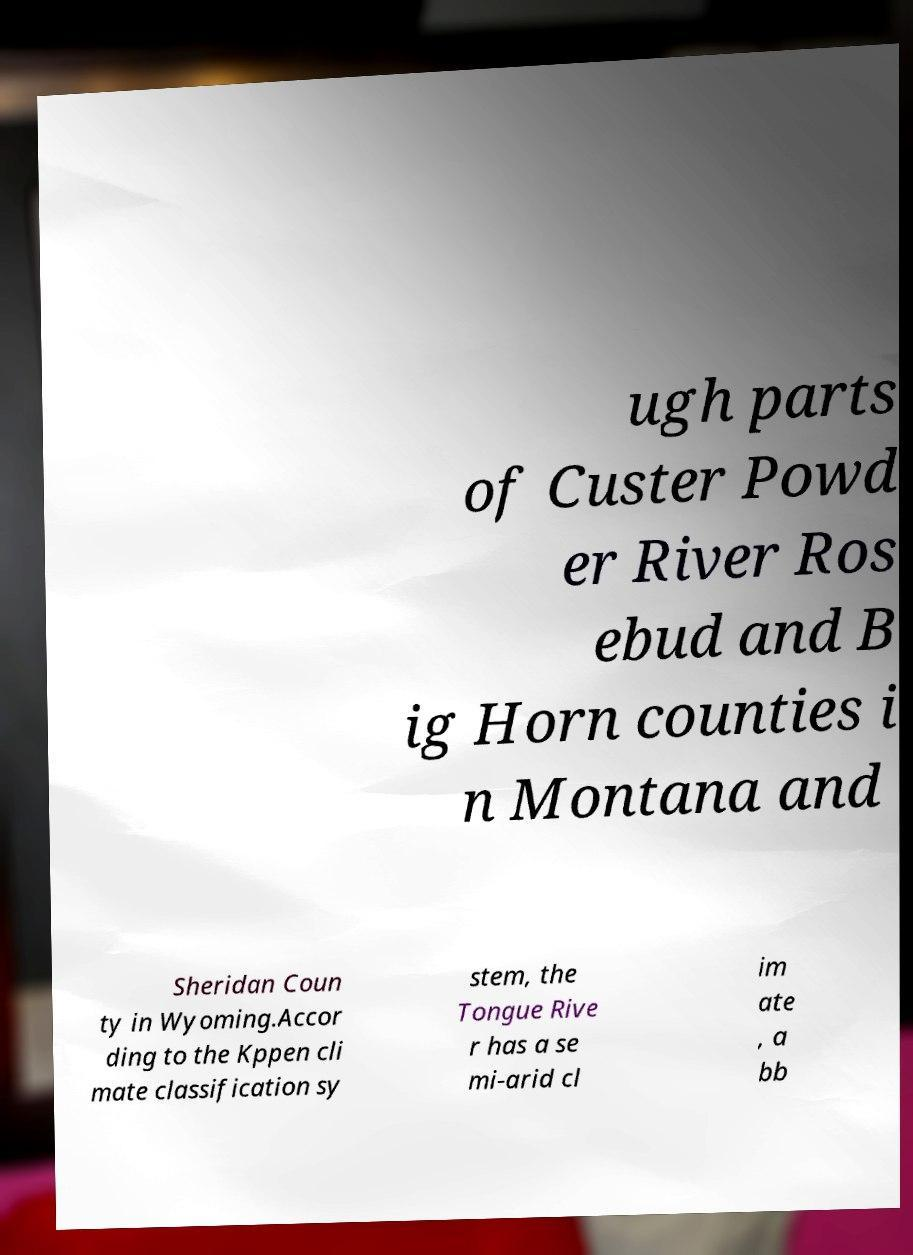I need the written content from this picture converted into text. Can you do that? ugh parts of Custer Powd er River Ros ebud and B ig Horn counties i n Montana and Sheridan Coun ty in Wyoming.Accor ding to the Kppen cli mate classification sy stem, the Tongue Rive r has a se mi-arid cl im ate , a bb 